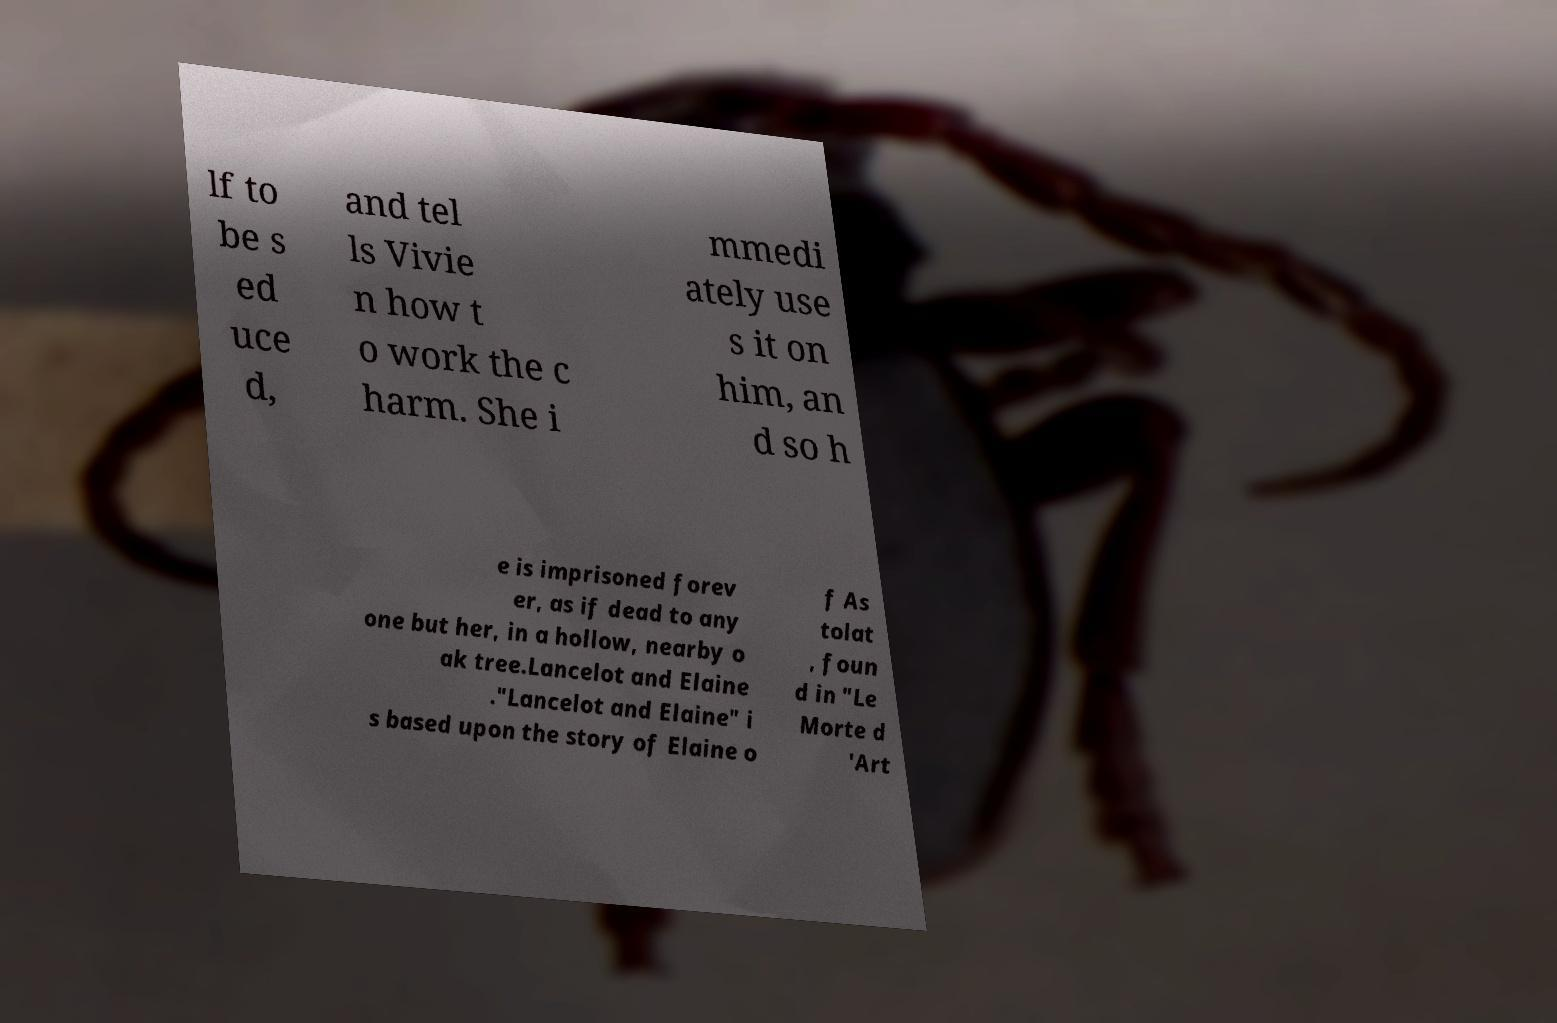I need the written content from this picture converted into text. Can you do that? lf to be s ed uce d, and tel ls Vivie n how t o work the c harm. She i mmedi ately use s it on him, an d so h e is imprisoned forev er, as if dead to any one but her, in a hollow, nearby o ak tree.Lancelot and Elaine ."Lancelot and Elaine" i s based upon the story of Elaine o f As tolat , foun d in "Le Morte d 'Art 